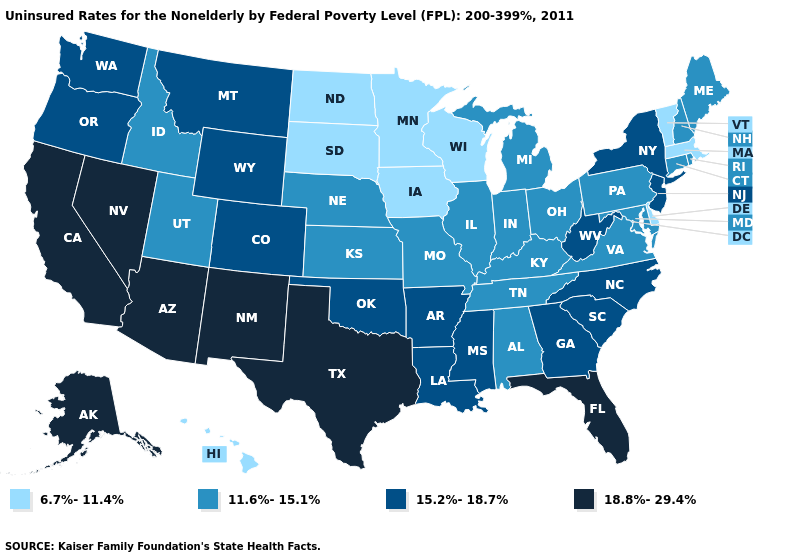What is the highest value in states that border Rhode Island?
Write a very short answer. 11.6%-15.1%. Which states have the lowest value in the USA?
Keep it brief. Delaware, Hawaii, Iowa, Massachusetts, Minnesota, North Dakota, South Dakota, Vermont, Wisconsin. Among the states that border Pennsylvania , which have the highest value?
Concise answer only. New Jersey, New York, West Virginia. Does the first symbol in the legend represent the smallest category?
Give a very brief answer. Yes. Among the states that border Missouri , which have the lowest value?
Write a very short answer. Iowa. Does Missouri have the lowest value in the USA?
Write a very short answer. No. What is the highest value in the USA?
Quick response, please. 18.8%-29.4%. Does South Carolina have a higher value than North Carolina?
Be succinct. No. What is the lowest value in the USA?
Keep it brief. 6.7%-11.4%. What is the value of New York?
Answer briefly. 15.2%-18.7%. Name the states that have a value in the range 11.6%-15.1%?
Be succinct. Alabama, Connecticut, Idaho, Illinois, Indiana, Kansas, Kentucky, Maine, Maryland, Michigan, Missouri, Nebraska, New Hampshire, Ohio, Pennsylvania, Rhode Island, Tennessee, Utah, Virginia. Name the states that have a value in the range 15.2%-18.7%?
Keep it brief. Arkansas, Colorado, Georgia, Louisiana, Mississippi, Montana, New Jersey, New York, North Carolina, Oklahoma, Oregon, South Carolina, Washington, West Virginia, Wyoming. Does the first symbol in the legend represent the smallest category?
Write a very short answer. Yes. Does the first symbol in the legend represent the smallest category?
Give a very brief answer. Yes. What is the value of Indiana?
Short answer required. 11.6%-15.1%. 